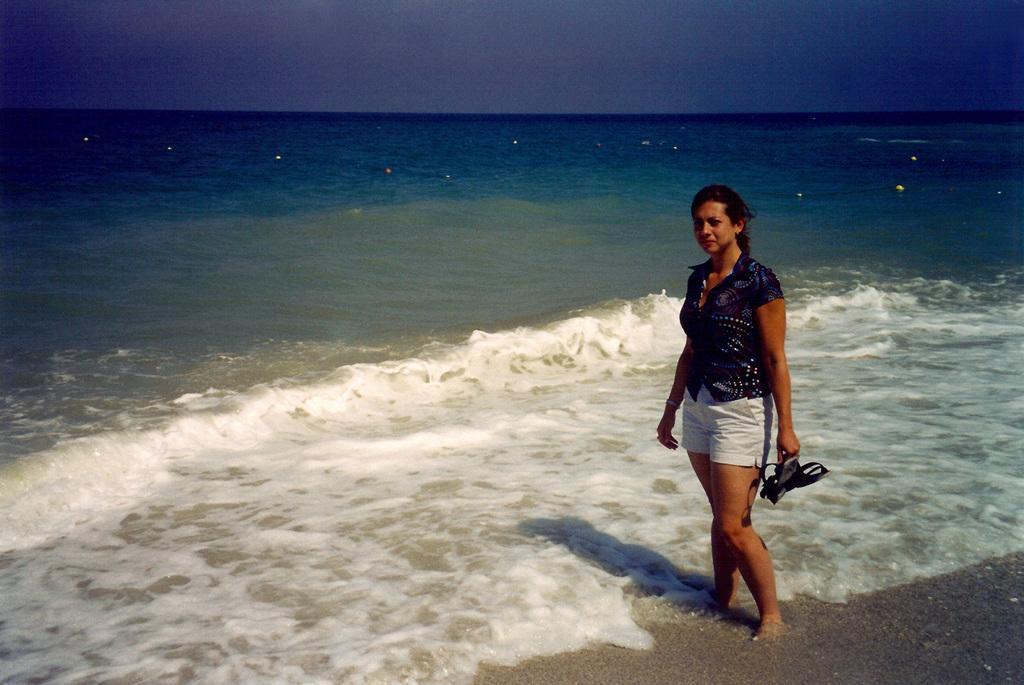Can you describe this image briefly? In the picture I can see a woman is standing and holding an object in the hand. In the background I can see the water and the sky. 